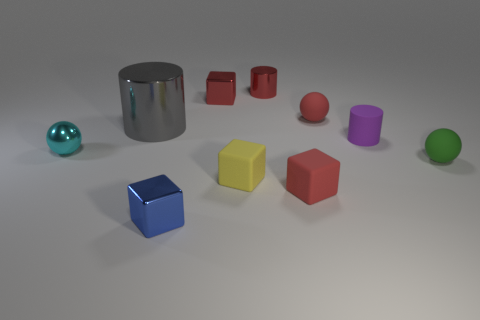What number of objects are either gray shiny spheres or metallic things in front of the gray metallic thing?
Your answer should be very brief. 2. Are there fewer tiny matte balls that are on the left side of the tiny yellow rubber object than cyan spheres behind the tiny red matte sphere?
Your answer should be compact. No. What number of other things are there of the same material as the tiny blue cube
Your response must be concise. 4. Is the color of the shiny object in front of the small cyan metal thing the same as the big shiny thing?
Ensure brevity in your answer.  No. There is a tiny red metal thing that is left of the yellow thing; is there a large cylinder behind it?
Your answer should be very brief. No. There is a sphere that is both on the right side of the small metal sphere and left of the green rubber sphere; what is its material?
Keep it short and to the point. Rubber. What is the shape of the small purple object that is made of the same material as the yellow object?
Keep it short and to the point. Cylinder. Are there any other things that have the same shape as the yellow rubber thing?
Provide a succinct answer. Yes. Is the material of the tiny red cube that is in front of the green sphere the same as the yellow object?
Offer a terse response. Yes. What is the material of the cube behind the tiny green object?
Offer a terse response. Metal. 